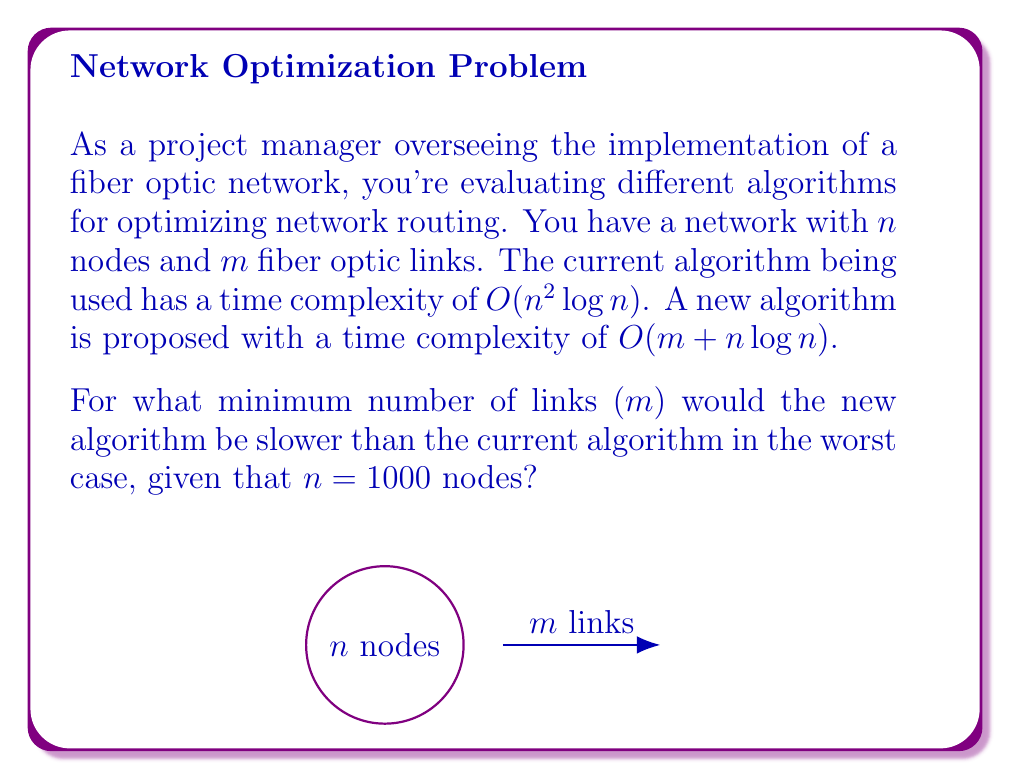Can you answer this question? Let's approach this step-by-step:

1) The current algorithm has a time complexity of $O(n^2 \log n)$.

2) The new algorithm has a time complexity of $O(m + n \log n)$.

3) We want to find the minimum $m$ for which the new algorithm is slower. This occurs when:

   $m + n \log n > n^2 \log n$

4) We're given that $n = 1000$. Let's substitute this:

   $m + 1000 \log 1000 > 1000^2 \log 1000$

5) Simplify:
   $m + 1000 \cdot 3 > 1000^2 \cdot 3$
   $m + 3000 > 3,000,000$

6) Solve for $m$:
   $m > 3,000,000 - 3000$
   $m > 2,997,000$

7) Since $m$ must be an integer, the minimum value for $m$ is:

   $m = 2,997,001$

Therefore, the new algorithm would be slower when there are at least 2,997,001 links in the network.
Answer: 2,997,001 links 